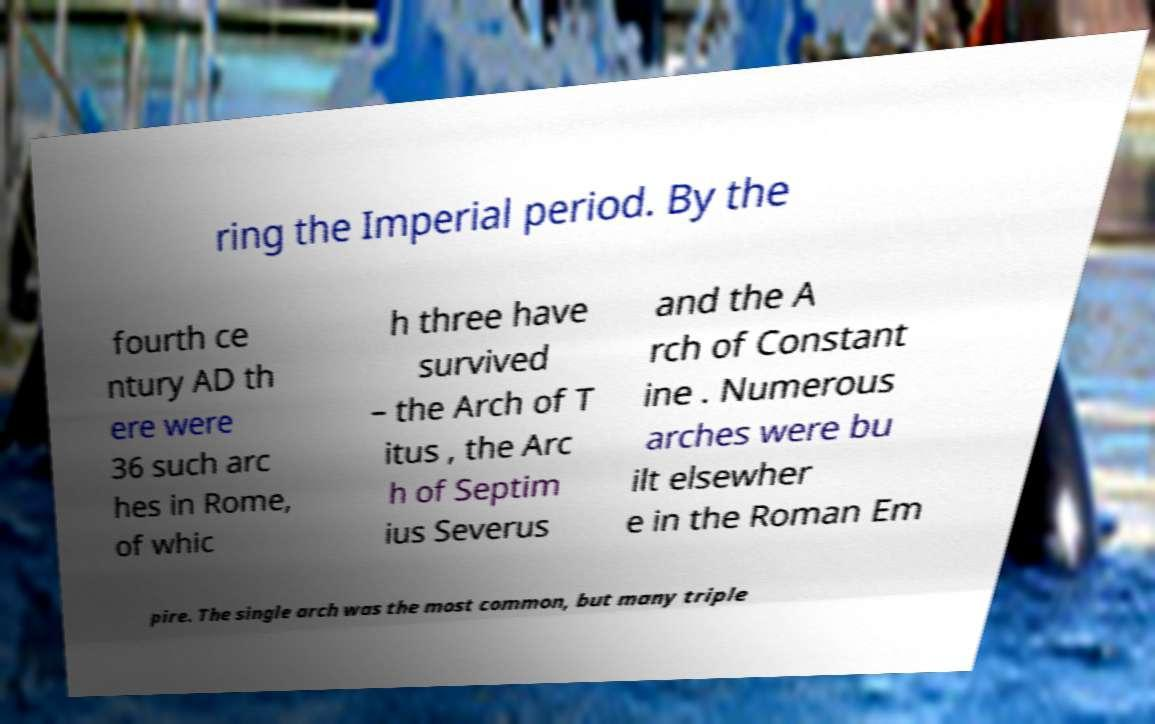Can you accurately transcribe the text from the provided image for me? ring the Imperial period. By the fourth ce ntury AD th ere were 36 such arc hes in Rome, of whic h three have survived – the Arch of T itus , the Arc h of Septim ius Severus and the A rch of Constant ine . Numerous arches were bu ilt elsewher e in the Roman Em pire. The single arch was the most common, but many triple 